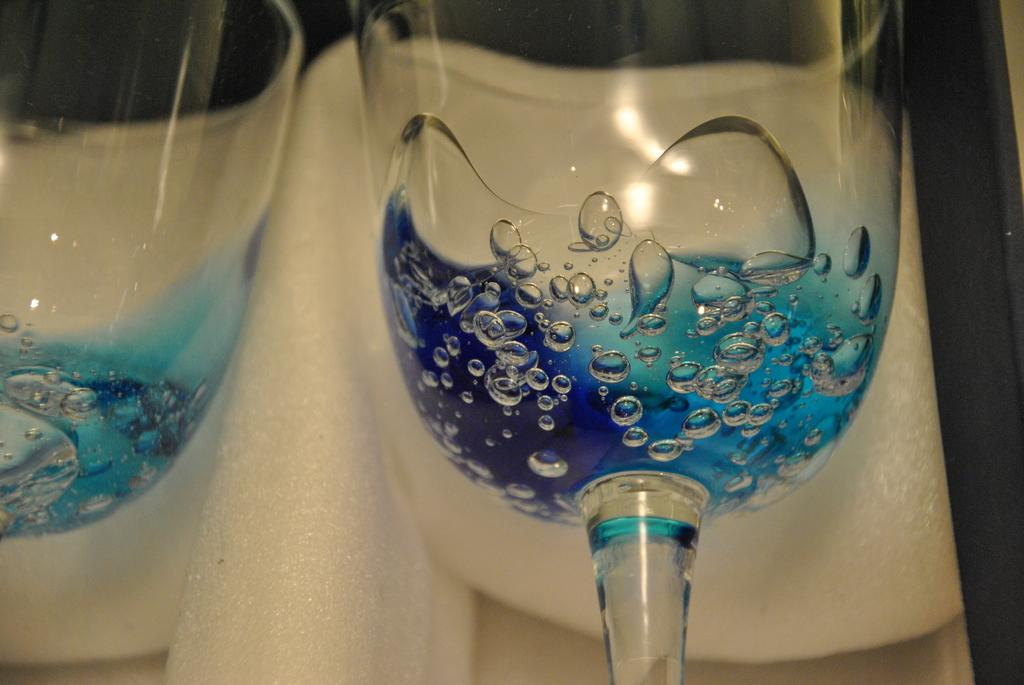What can be seen in the image that is related to water? There are water drops in the image. What objects are present in the image that can hold liquids? There are glasses in the image. On what surface are the glasses placed? The glasses are on a white object. What type of knowledge is being transferred through the water drops in the image? There is no indication of knowledge transfer in the image; it simply shows water drops. What force is causing the water drops to move in the image? There is no indication of any force causing the water drops to move in the image; they appear to be stationary. 